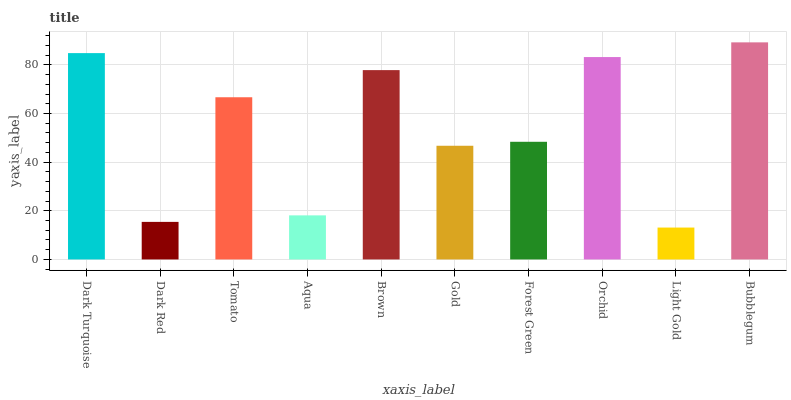Is Light Gold the minimum?
Answer yes or no. Yes. Is Bubblegum the maximum?
Answer yes or no. Yes. Is Dark Red the minimum?
Answer yes or no. No. Is Dark Red the maximum?
Answer yes or no. No. Is Dark Turquoise greater than Dark Red?
Answer yes or no. Yes. Is Dark Red less than Dark Turquoise?
Answer yes or no. Yes. Is Dark Red greater than Dark Turquoise?
Answer yes or no. No. Is Dark Turquoise less than Dark Red?
Answer yes or no. No. Is Tomato the high median?
Answer yes or no. Yes. Is Forest Green the low median?
Answer yes or no. Yes. Is Light Gold the high median?
Answer yes or no. No. Is Gold the low median?
Answer yes or no. No. 